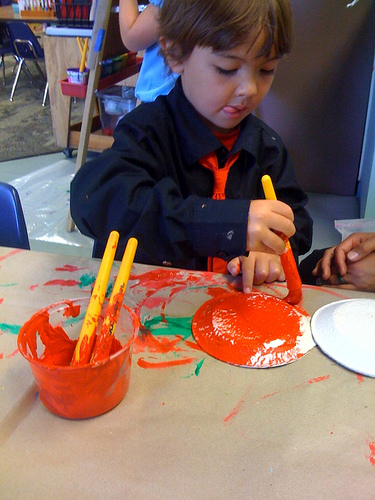How many cups are in the photo? There is one cup visible in the photo, prominently holding some vibrant red paint and accompanied by three paintbrushes, which suggests an artistic activity is taking place. 